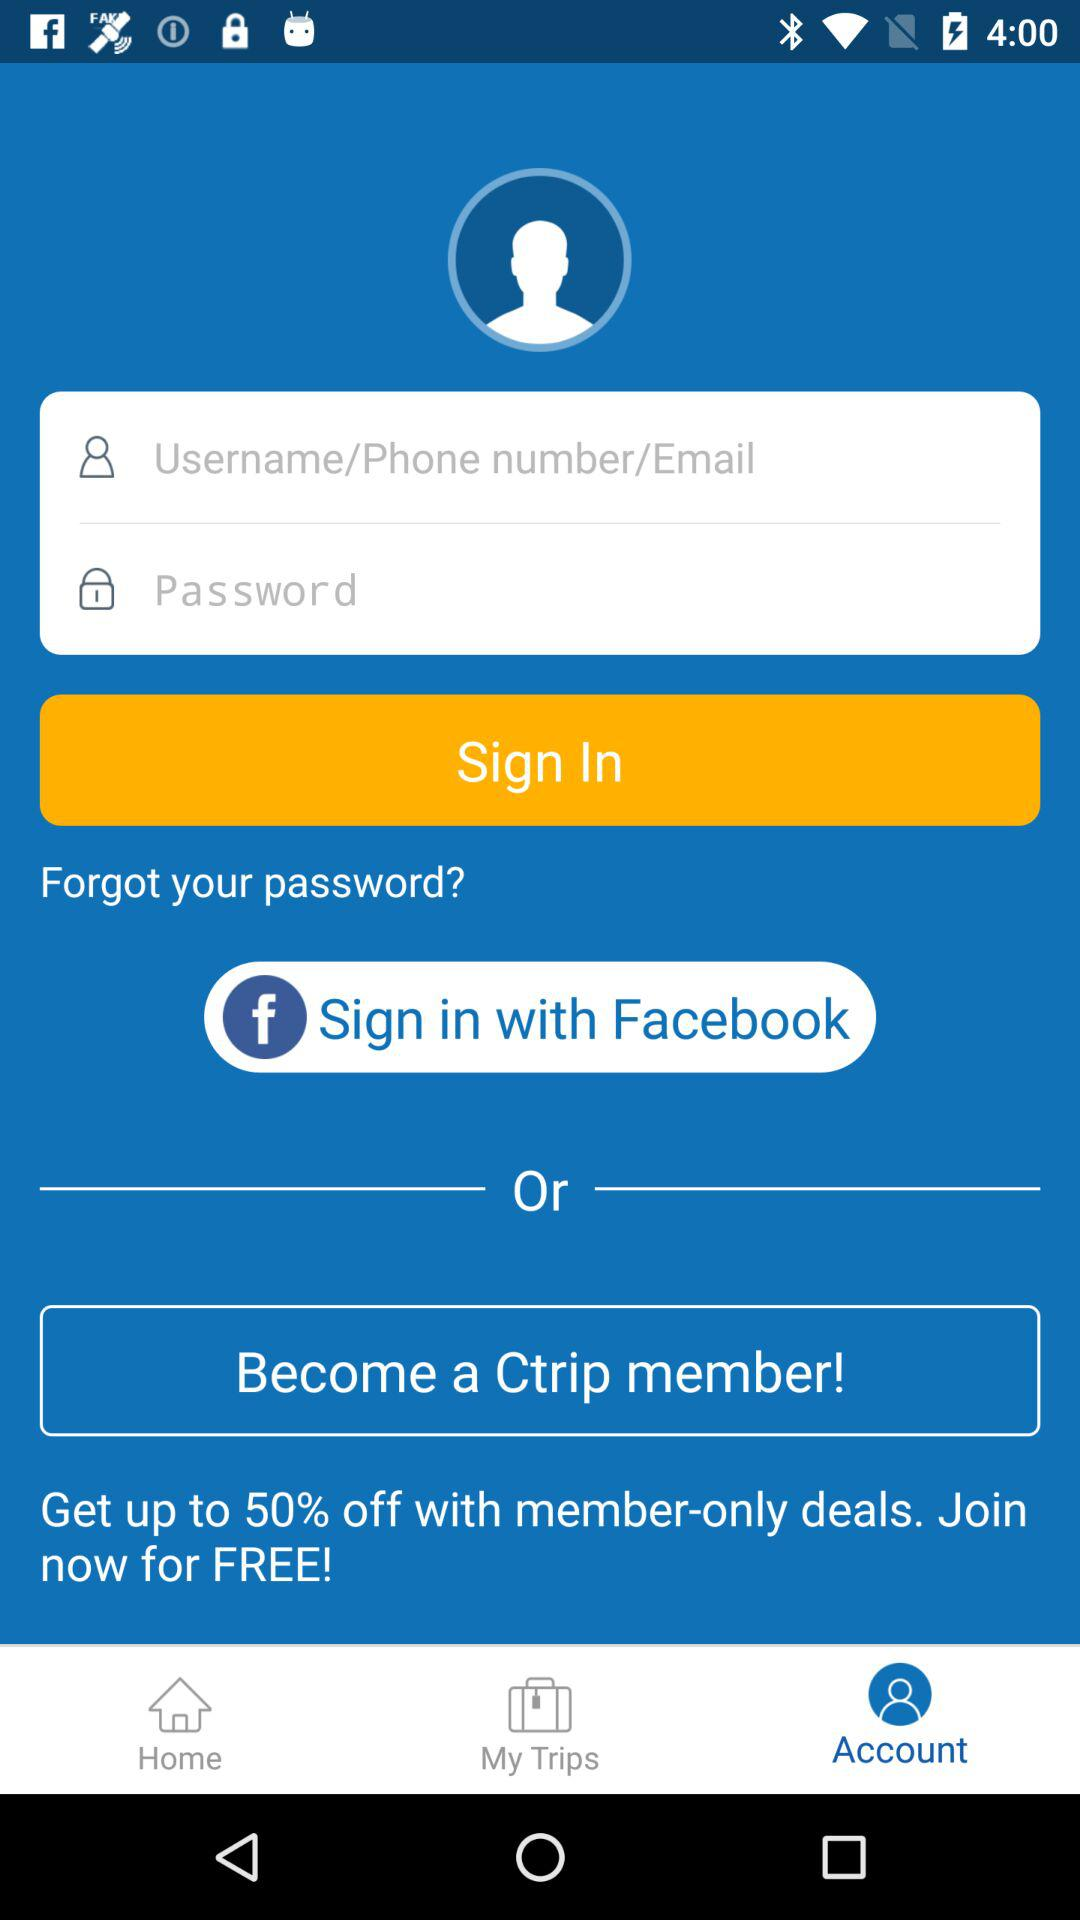What application can we use to sign in? You can use "Facebook" to sign in. 